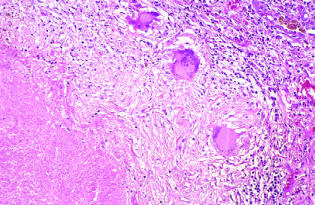does the pattern of staining of anti-centromere antibodies take the form of a three-dimensional sphere with the offending organism in the central area?
Answer the question using a single word or phrase. No 